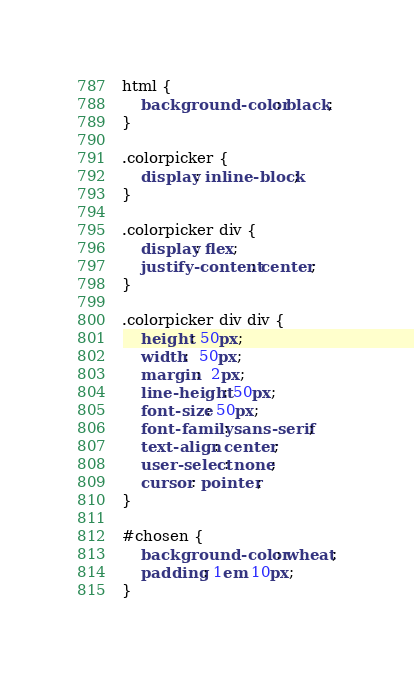Convert code to text. <code><loc_0><loc_0><loc_500><loc_500><_CSS_>html {
	background-color: black;
}

.colorpicker {
	display: inline-block;
}

.colorpicker div {
	display: flex;
	justify-content: center;
}

.colorpicker div div {
	height: 50px;
	width:  50px;
	margin:  2px;
	line-height: 50px;
	font-size: 50px;
	font-family: sans-serif;
	text-align: center;
	user-select: none;
	cursor: pointer;
}

#chosen {
	background-color: wheat;
	padding: 1em 10px;
}
</code> 